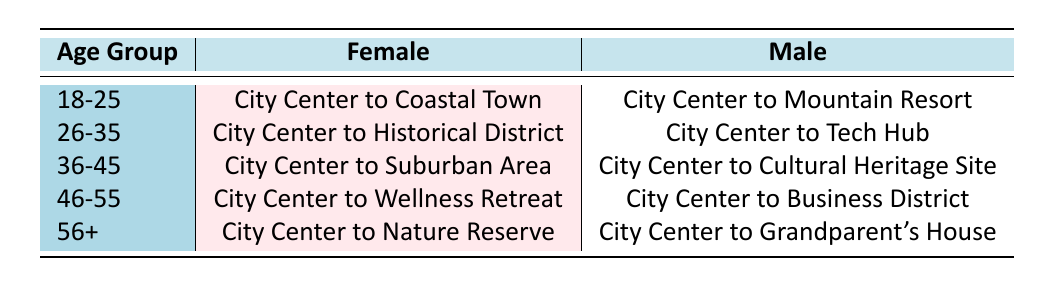What is the preferred train route for females aged 36-45? According to the table, females aged 36-45 prefer the route "City Center to Suburban Area" as listed under that age group in the Female column.
Answer: City Center to Suburban Area What is the preferred train route for males aged 46-55? The table shows that males aged 46-55 prefer the route "City Center to Business District" as it is indicated in the Male column for that age group.
Answer: City Center to Business District Are there more preferred train routes for males or females aged 18-25? In the age group 18-25, there are two preferred routes: "City Center to Coastal Town" for females and "City Center to Mountain Resort" for males, indicating that both genders have one route each. Therefore, there are equal preferred routes for both males and females in this age group.
Answer: No Which age group has the route "City Center to Nature Reserve"? The route "City Center to Nature Reserve" is preferred by the females in the age group 56+, as specified in the table under that respective age and gender.
Answer: 56+ What is the difference in preferred routes between males and females aged 26-35? Females aged 26-35 prefer the route "City Center to Historical District," while males in the same age group prefer "City Center to Tech Hub." Therefore, there is a difference in preferred routes as one is historical while the other is tech-focused.
Answer: Different routes Which age group has the most distinct route preferences for males? Upon reviewing the table, males aged 46-55 have the route "City Center to Business District," which is distinct from others because it focuses on business, whereas other age groups have more leisure-focused routes. This distinction highlights a preference for a more urban and pragmatic experience for this demographic.
Answer: 46-55 